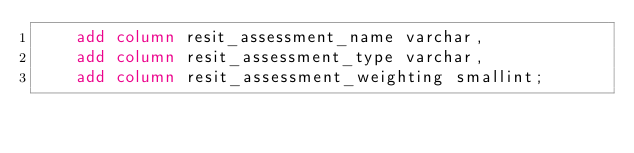<code> <loc_0><loc_0><loc_500><loc_500><_SQL_>    add column resit_assessment_name varchar,
    add column resit_assessment_type varchar,
    add column resit_assessment_weighting smallint;
</code> 